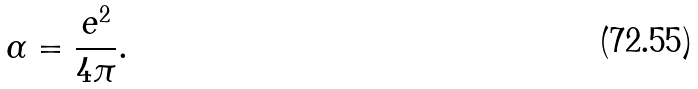Convert formula to latex. <formula><loc_0><loc_0><loc_500><loc_500>\alpha = { \frac { e ^ { 2 } } { 4 \pi } } .</formula> 